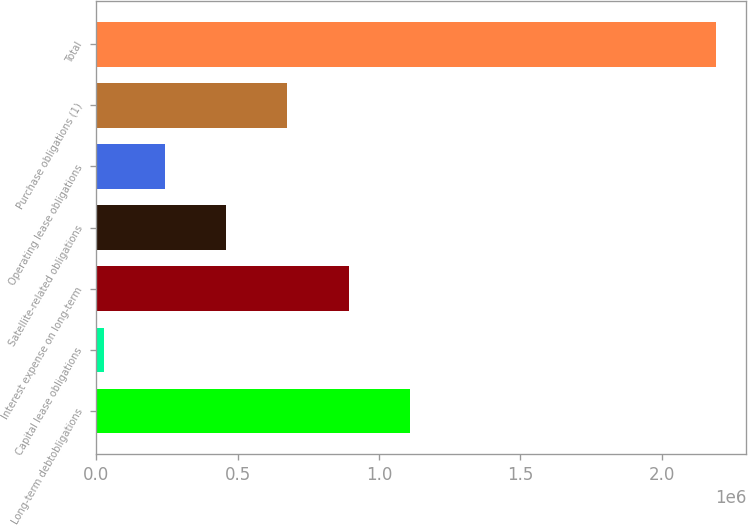Convert chart to OTSL. <chart><loc_0><loc_0><loc_500><loc_500><bar_chart><fcel>Long-term debtobligations<fcel>Capital lease obligations<fcel>Interest expense on long-term<fcel>Satellite-related obligations<fcel>Operating lease obligations<fcel>Purchase obligations (1)<fcel>Total<nl><fcel>1.10859e+06<fcel>27339<fcel>892338<fcel>459838<fcel>243589<fcel>676088<fcel>2.18984e+06<nl></chart> 